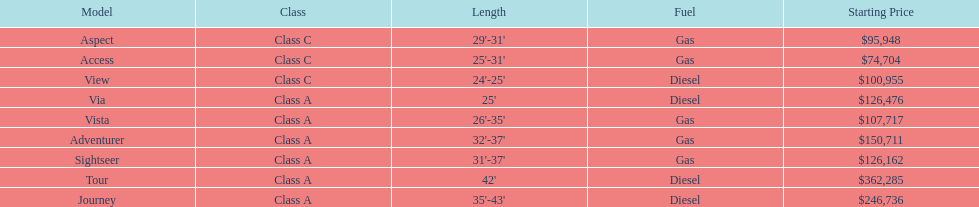Which model had the highest starting price Tour. 